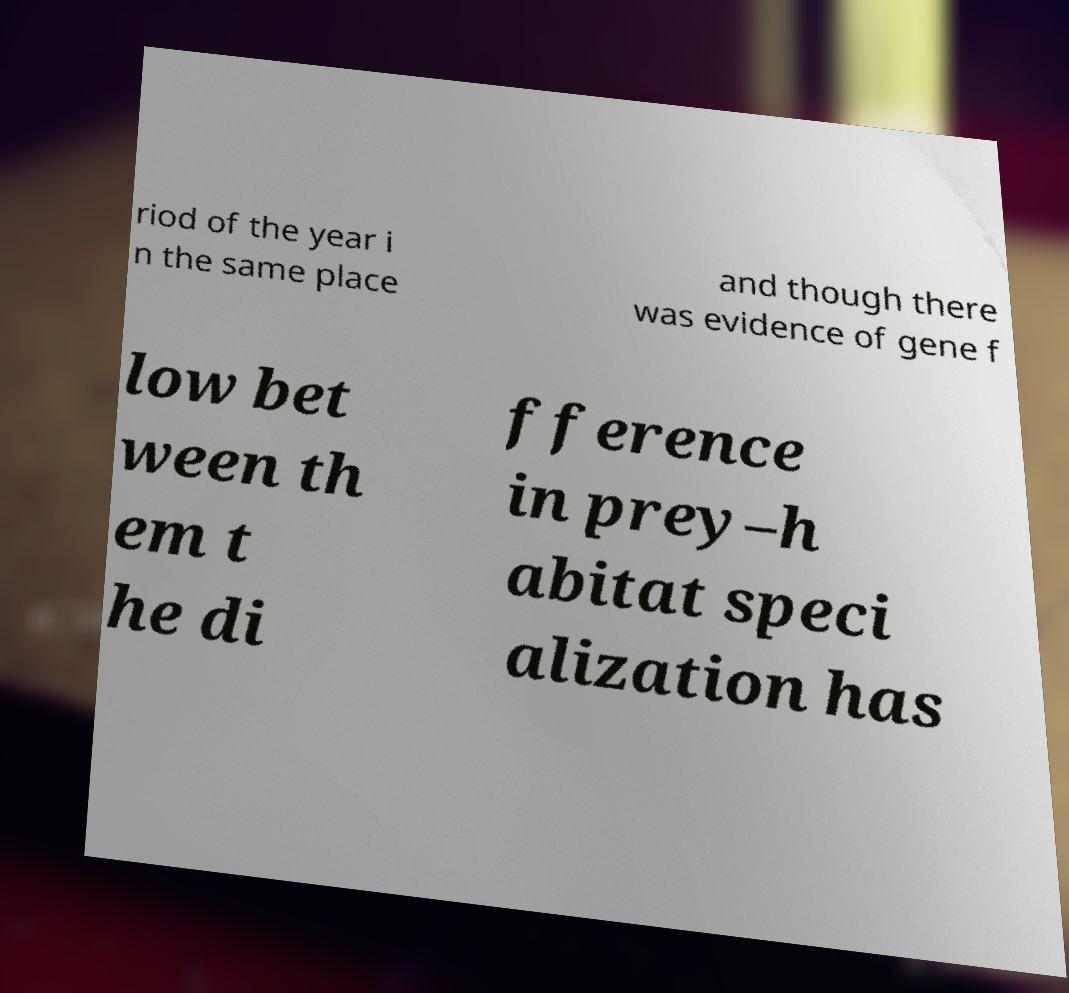Can you read and provide the text displayed in the image?This photo seems to have some interesting text. Can you extract and type it out for me? riod of the year i n the same place and though there was evidence of gene f low bet ween th em t he di fference in prey–h abitat speci alization has 